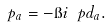Convert formula to latex. <formula><loc_0><loc_0><loc_500><loc_500>p _ { a } = - \i i \ p d _ { a } .</formula> 